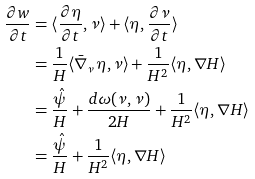Convert formula to latex. <formula><loc_0><loc_0><loc_500><loc_500>\frac { \partial w } { \partial t } & = \langle \frac { \partial \eta } { \partial t } , \nu \rangle + \langle \eta , \frac { \partial \nu } { \partial t } \rangle \\ & = \frac { 1 } { H } \langle \bar { \nabla } _ { \nu } \eta , \nu \rangle + \frac { 1 } { H ^ { 2 } } \langle \eta , \nabla H \rangle \\ & = \frac { \hat { \psi } } { H } + \frac { d \omega ( \nu , \nu ) } { 2 H } + \frac { 1 } { H ^ { 2 } } \langle \eta , \nabla H \rangle \\ & = \frac { \hat { \psi } } { H } + \frac { 1 } { H ^ { 2 } } \langle \eta , \nabla H \rangle</formula> 